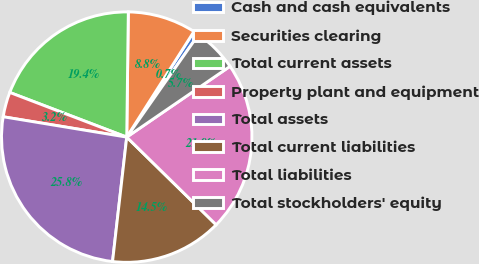<chart> <loc_0><loc_0><loc_500><loc_500><pie_chart><fcel>Cash and cash equivalents<fcel>Securities clearing<fcel>Total current assets<fcel>Property plant and equipment<fcel>Total assets<fcel>Total current liabilities<fcel>Total liabilities<fcel>Total stockholders' equity<nl><fcel>0.7%<fcel>8.82%<fcel>19.4%<fcel>3.21%<fcel>25.8%<fcel>14.47%<fcel>21.91%<fcel>5.72%<nl></chart> 